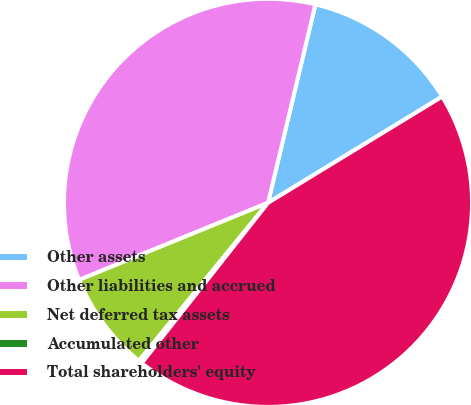Convert chart. <chart><loc_0><loc_0><loc_500><loc_500><pie_chart><fcel>Other assets<fcel>Other liabilities and accrued<fcel>Net deferred tax assets<fcel>Accumulated other<fcel>Total shareholders' equity<nl><fcel>12.55%<fcel>34.89%<fcel>7.93%<fcel>0.28%<fcel>44.34%<nl></chart> 